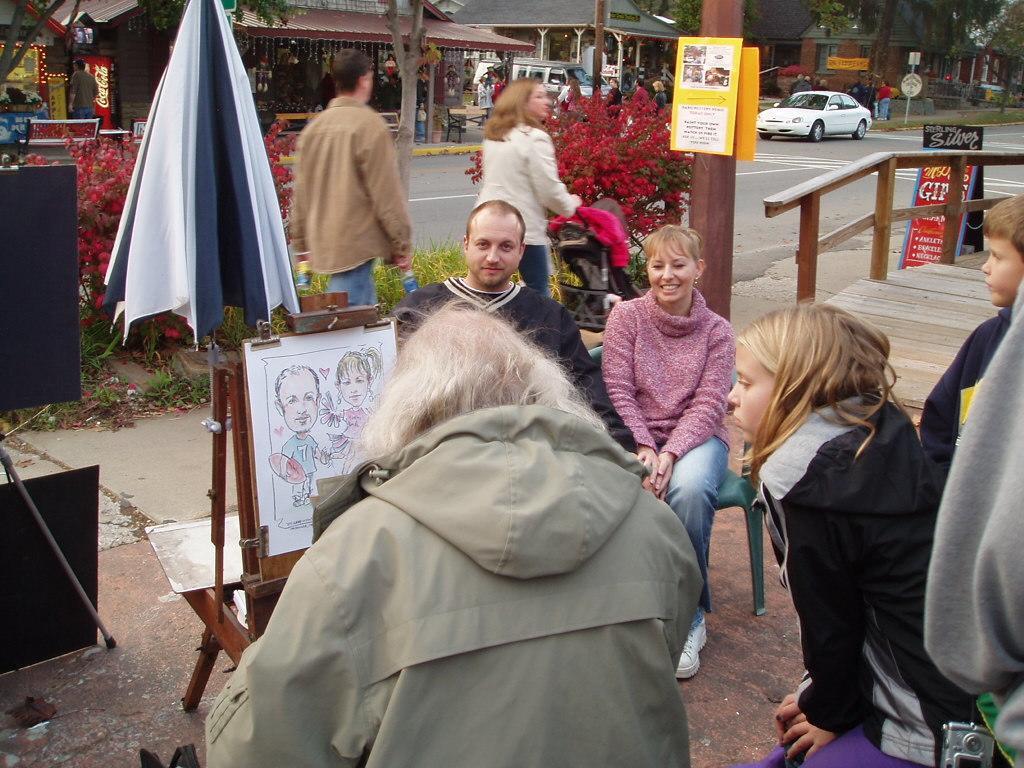Please provide a concise description of this image. In this picture there are two people sitting on the chairs and smiling. In the foreground there are group of people standing and there are pictures of two people on the paper and there is an umbrella and there are objects. At the back there are two people walking and there is a vehicle on the road and there are buildings and trees and there are group of people and there are boards on the poles and there is text on the boards and there are plants. On the right side of the image there is a wooden railing. At the bottom there is a road. 